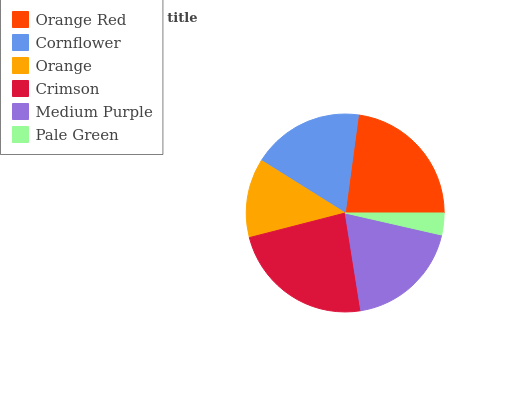Is Pale Green the minimum?
Answer yes or no. Yes. Is Crimson the maximum?
Answer yes or no. Yes. Is Cornflower the minimum?
Answer yes or no. No. Is Cornflower the maximum?
Answer yes or no. No. Is Orange Red greater than Cornflower?
Answer yes or no. Yes. Is Cornflower less than Orange Red?
Answer yes or no. Yes. Is Cornflower greater than Orange Red?
Answer yes or no. No. Is Orange Red less than Cornflower?
Answer yes or no. No. Is Medium Purple the high median?
Answer yes or no. Yes. Is Cornflower the low median?
Answer yes or no. Yes. Is Orange Red the high median?
Answer yes or no. No. Is Orange the low median?
Answer yes or no. No. 